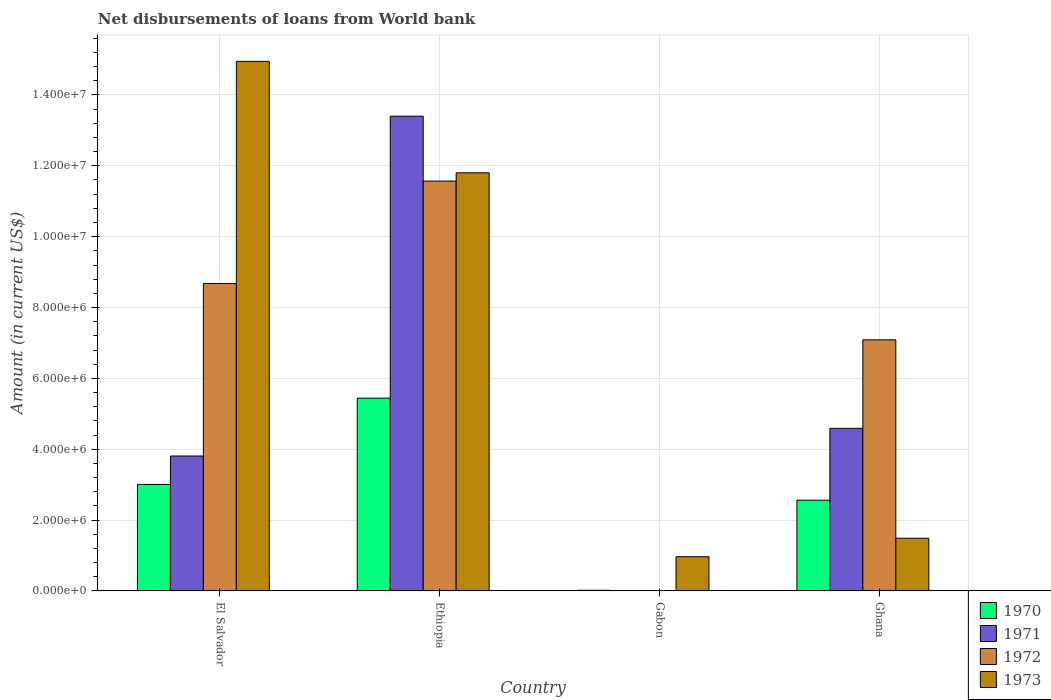How many different coloured bars are there?
Provide a succinct answer. 4. Are the number of bars per tick equal to the number of legend labels?
Your answer should be very brief. No. Are the number of bars on each tick of the X-axis equal?
Give a very brief answer. No. How many bars are there on the 1st tick from the left?
Your response must be concise. 4. What is the label of the 2nd group of bars from the left?
Keep it short and to the point. Ethiopia. In how many cases, is the number of bars for a given country not equal to the number of legend labels?
Offer a very short reply. 1. What is the amount of loan disbursed from World Bank in 1973 in Gabon?
Your answer should be very brief. 9.67e+05. Across all countries, what is the maximum amount of loan disbursed from World Bank in 1972?
Make the answer very short. 1.16e+07. In which country was the amount of loan disbursed from World Bank in 1971 maximum?
Your answer should be very brief. Ethiopia. What is the total amount of loan disbursed from World Bank in 1973 in the graph?
Provide a succinct answer. 2.92e+07. What is the difference between the amount of loan disbursed from World Bank in 1970 in Ethiopia and that in Ghana?
Offer a very short reply. 2.88e+06. What is the difference between the amount of loan disbursed from World Bank in 1972 in Ghana and the amount of loan disbursed from World Bank in 1971 in Ethiopia?
Your answer should be compact. -6.31e+06. What is the average amount of loan disbursed from World Bank in 1970 per country?
Offer a terse response. 2.76e+06. What is the difference between the amount of loan disbursed from World Bank of/in 1972 and amount of loan disbursed from World Bank of/in 1971 in Ethiopia?
Give a very brief answer. -1.83e+06. In how many countries, is the amount of loan disbursed from World Bank in 1973 greater than 800000 US$?
Your answer should be compact. 4. What is the ratio of the amount of loan disbursed from World Bank in 1971 in El Salvador to that in Ghana?
Your answer should be compact. 0.83. What is the difference between the highest and the second highest amount of loan disbursed from World Bank in 1970?
Ensure brevity in your answer.  2.44e+06. What is the difference between the highest and the lowest amount of loan disbursed from World Bank in 1970?
Ensure brevity in your answer.  5.42e+06. Is it the case that in every country, the sum of the amount of loan disbursed from World Bank in 1973 and amount of loan disbursed from World Bank in 1971 is greater than the amount of loan disbursed from World Bank in 1970?
Offer a very short reply. Yes. How many bars are there?
Your answer should be very brief. 14. How many countries are there in the graph?
Offer a terse response. 4. Are the values on the major ticks of Y-axis written in scientific E-notation?
Your answer should be compact. Yes. Does the graph contain any zero values?
Your answer should be compact. Yes. How many legend labels are there?
Make the answer very short. 4. How are the legend labels stacked?
Your answer should be very brief. Vertical. What is the title of the graph?
Give a very brief answer. Net disbursements of loans from World bank. What is the Amount (in current US$) of 1970 in El Salvador?
Your answer should be very brief. 3.01e+06. What is the Amount (in current US$) of 1971 in El Salvador?
Give a very brief answer. 3.81e+06. What is the Amount (in current US$) in 1972 in El Salvador?
Offer a very short reply. 8.68e+06. What is the Amount (in current US$) in 1973 in El Salvador?
Your answer should be compact. 1.49e+07. What is the Amount (in current US$) in 1970 in Ethiopia?
Ensure brevity in your answer.  5.44e+06. What is the Amount (in current US$) of 1971 in Ethiopia?
Offer a terse response. 1.34e+07. What is the Amount (in current US$) in 1972 in Ethiopia?
Provide a short and direct response. 1.16e+07. What is the Amount (in current US$) of 1973 in Ethiopia?
Ensure brevity in your answer.  1.18e+07. What is the Amount (in current US$) of 1970 in Gabon?
Your answer should be compact. 2.00e+04. What is the Amount (in current US$) of 1971 in Gabon?
Offer a very short reply. 0. What is the Amount (in current US$) of 1973 in Gabon?
Ensure brevity in your answer.  9.67e+05. What is the Amount (in current US$) of 1970 in Ghana?
Provide a short and direct response. 2.56e+06. What is the Amount (in current US$) of 1971 in Ghana?
Keep it short and to the point. 4.59e+06. What is the Amount (in current US$) in 1972 in Ghana?
Offer a very short reply. 7.09e+06. What is the Amount (in current US$) of 1973 in Ghana?
Provide a succinct answer. 1.49e+06. Across all countries, what is the maximum Amount (in current US$) in 1970?
Your answer should be compact. 5.44e+06. Across all countries, what is the maximum Amount (in current US$) in 1971?
Give a very brief answer. 1.34e+07. Across all countries, what is the maximum Amount (in current US$) of 1972?
Your answer should be compact. 1.16e+07. Across all countries, what is the maximum Amount (in current US$) in 1973?
Offer a very short reply. 1.49e+07. Across all countries, what is the minimum Amount (in current US$) of 1970?
Ensure brevity in your answer.  2.00e+04. Across all countries, what is the minimum Amount (in current US$) of 1971?
Your answer should be very brief. 0. Across all countries, what is the minimum Amount (in current US$) in 1972?
Your answer should be compact. 0. Across all countries, what is the minimum Amount (in current US$) of 1973?
Offer a very short reply. 9.67e+05. What is the total Amount (in current US$) of 1970 in the graph?
Ensure brevity in your answer.  1.10e+07. What is the total Amount (in current US$) of 1971 in the graph?
Keep it short and to the point. 2.18e+07. What is the total Amount (in current US$) in 1972 in the graph?
Provide a succinct answer. 2.73e+07. What is the total Amount (in current US$) of 1973 in the graph?
Keep it short and to the point. 2.92e+07. What is the difference between the Amount (in current US$) of 1970 in El Salvador and that in Ethiopia?
Your answer should be compact. -2.44e+06. What is the difference between the Amount (in current US$) in 1971 in El Salvador and that in Ethiopia?
Provide a short and direct response. -9.59e+06. What is the difference between the Amount (in current US$) of 1972 in El Salvador and that in Ethiopia?
Your answer should be very brief. -2.89e+06. What is the difference between the Amount (in current US$) of 1973 in El Salvador and that in Ethiopia?
Provide a short and direct response. 3.15e+06. What is the difference between the Amount (in current US$) in 1970 in El Salvador and that in Gabon?
Your answer should be very brief. 2.99e+06. What is the difference between the Amount (in current US$) of 1973 in El Salvador and that in Gabon?
Make the answer very short. 1.40e+07. What is the difference between the Amount (in current US$) in 1970 in El Salvador and that in Ghana?
Keep it short and to the point. 4.45e+05. What is the difference between the Amount (in current US$) in 1971 in El Salvador and that in Ghana?
Keep it short and to the point. -7.81e+05. What is the difference between the Amount (in current US$) in 1972 in El Salvador and that in Ghana?
Give a very brief answer. 1.59e+06. What is the difference between the Amount (in current US$) in 1973 in El Salvador and that in Ghana?
Keep it short and to the point. 1.35e+07. What is the difference between the Amount (in current US$) in 1970 in Ethiopia and that in Gabon?
Your response must be concise. 5.42e+06. What is the difference between the Amount (in current US$) in 1973 in Ethiopia and that in Gabon?
Keep it short and to the point. 1.08e+07. What is the difference between the Amount (in current US$) of 1970 in Ethiopia and that in Ghana?
Keep it short and to the point. 2.88e+06. What is the difference between the Amount (in current US$) of 1971 in Ethiopia and that in Ghana?
Your answer should be very brief. 8.81e+06. What is the difference between the Amount (in current US$) of 1972 in Ethiopia and that in Ghana?
Your answer should be very brief. 4.48e+06. What is the difference between the Amount (in current US$) of 1973 in Ethiopia and that in Ghana?
Your answer should be compact. 1.03e+07. What is the difference between the Amount (in current US$) in 1970 in Gabon and that in Ghana?
Provide a succinct answer. -2.54e+06. What is the difference between the Amount (in current US$) in 1973 in Gabon and that in Ghana?
Provide a succinct answer. -5.21e+05. What is the difference between the Amount (in current US$) of 1970 in El Salvador and the Amount (in current US$) of 1971 in Ethiopia?
Offer a very short reply. -1.04e+07. What is the difference between the Amount (in current US$) in 1970 in El Salvador and the Amount (in current US$) in 1972 in Ethiopia?
Your answer should be very brief. -8.56e+06. What is the difference between the Amount (in current US$) in 1970 in El Salvador and the Amount (in current US$) in 1973 in Ethiopia?
Ensure brevity in your answer.  -8.80e+06. What is the difference between the Amount (in current US$) of 1971 in El Salvador and the Amount (in current US$) of 1972 in Ethiopia?
Give a very brief answer. -7.76e+06. What is the difference between the Amount (in current US$) of 1971 in El Salvador and the Amount (in current US$) of 1973 in Ethiopia?
Your response must be concise. -7.99e+06. What is the difference between the Amount (in current US$) in 1972 in El Salvador and the Amount (in current US$) in 1973 in Ethiopia?
Your answer should be very brief. -3.12e+06. What is the difference between the Amount (in current US$) in 1970 in El Salvador and the Amount (in current US$) in 1973 in Gabon?
Provide a succinct answer. 2.04e+06. What is the difference between the Amount (in current US$) in 1971 in El Salvador and the Amount (in current US$) in 1973 in Gabon?
Keep it short and to the point. 2.84e+06. What is the difference between the Amount (in current US$) of 1972 in El Salvador and the Amount (in current US$) of 1973 in Gabon?
Your answer should be very brief. 7.71e+06. What is the difference between the Amount (in current US$) of 1970 in El Salvador and the Amount (in current US$) of 1971 in Ghana?
Ensure brevity in your answer.  -1.58e+06. What is the difference between the Amount (in current US$) in 1970 in El Salvador and the Amount (in current US$) in 1972 in Ghana?
Make the answer very short. -4.08e+06. What is the difference between the Amount (in current US$) of 1970 in El Salvador and the Amount (in current US$) of 1973 in Ghana?
Ensure brevity in your answer.  1.52e+06. What is the difference between the Amount (in current US$) in 1971 in El Salvador and the Amount (in current US$) in 1972 in Ghana?
Your response must be concise. -3.28e+06. What is the difference between the Amount (in current US$) of 1971 in El Salvador and the Amount (in current US$) of 1973 in Ghana?
Offer a terse response. 2.32e+06. What is the difference between the Amount (in current US$) of 1972 in El Salvador and the Amount (in current US$) of 1973 in Ghana?
Ensure brevity in your answer.  7.19e+06. What is the difference between the Amount (in current US$) in 1970 in Ethiopia and the Amount (in current US$) in 1973 in Gabon?
Provide a succinct answer. 4.48e+06. What is the difference between the Amount (in current US$) in 1971 in Ethiopia and the Amount (in current US$) in 1973 in Gabon?
Your answer should be compact. 1.24e+07. What is the difference between the Amount (in current US$) of 1972 in Ethiopia and the Amount (in current US$) of 1973 in Gabon?
Offer a very short reply. 1.06e+07. What is the difference between the Amount (in current US$) of 1970 in Ethiopia and the Amount (in current US$) of 1971 in Ghana?
Keep it short and to the point. 8.51e+05. What is the difference between the Amount (in current US$) of 1970 in Ethiopia and the Amount (in current US$) of 1972 in Ghana?
Keep it short and to the point. -1.65e+06. What is the difference between the Amount (in current US$) in 1970 in Ethiopia and the Amount (in current US$) in 1973 in Ghana?
Provide a short and direct response. 3.95e+06. What is the difference between the Amount (in current US$) of 1971 in Ethiopia and the Amount (in current US$) of 1972 in Ghana?
Your response must be concise. 6.31e+06. What is the difference between the Amount (in current US$) in 1971 in Ethiopia and the Amount (in current US$) in 1973 in Ghana?
Provide a succinct answer. 1.19e+07. What is the difference between the Amount (in current US$) of 1972 in Ethiopia and the Amount (in current US$) of 1973 in Ghana?
Keep it short and to the point. 1.01e+07. What is the difference between the Amount (in current US$) in 1970 in Gabon and the Amount (in current US$) in 1971 in Ghana?
Give a very brief answer. -4.57e+06. What is the difference between the Amount (in current US$) in 1970 in Gabon and the Amount (in current US$) in 1972 in Ghana?
Offer a terse response. -7.07e+06. What is the difference between the Amount (in current US$) of 1970 in Gabon and the Amount (in current US$) of 1973 in Ghana?
Keep it short and to the point. -1.47e+06. What is the average Amount (in current US$) in 1970 per country?
Make the answer very short. 2.76e+06. What is the average Amount (in current US$) in 1971 per country?
Make the answer very short. 5.45e+06. What is the average Amount (in current US$) in 1972 per country?
Ensure brevity in your answer.  6.83e+06. What is the average Amount (in current US$) of 1973 per country?
Offer a very short reply. 7.30e+06. What is the difference between the Amount (in current US$) of 1970 and Amount (in current US$) of 1971 in El Salvador?
Your answer should be very brief. -8.03e+05. What is the difference between the Amount (in current US$) in 1970 and Amount (in current US$) in 1972 in El Salvador?
Your answer should be very brief. -5.67e+06. What is the difference between the Amount (in current US$) of 1970 and Amount (in current US$) of 1973 in El Salvador?
Your answer should be very brief. -1.19e+07. What is the difference between the Amount (in current US$) in 1971 and Amount (in current US$) in 1972 in El Salvador?
Offer a terse response. -4.87e+06. What is the difference between the Amount (in current US$) of 1971 and Amount (in current US$) of 1973 in El Salvador?
Offer a very short reply. -1.11e+07. What is the difference between the Amount (in current US$) in 1972 and Amount (in current US$) in 1973 in El Salvador?
Provide a short and direct response. -6.27e+06. What is the difference between the Amount (in current US$) in 1970 and Amount (in current US$) in 1971 in Ethiopia?
Offer a very short reply. -7.96e+06. What is the difference between the Amount (in current US$) in 1970 and Amount (in current US$) in 1972 in Ethiopia?
Offer a terse response. -6.13e+06. What is the difference between the Amount (in current US$) in 1970 and Amount (in current US$) in 1973 in Ethiopia?
Your answer should be compact. -6.36e+06. What is the difference between the Amount (in current US$) in 1971 and Amount (in current US$) in 1972 in Ethiopia?
Your answer should be very brief. 1.83e+06. What is the difference between the Amount (in current US$) of 1971 and Amount (in current US$) of 1973 in Ethiopia?
Your response must be concise. 1.60e+06. What is the difference between the Amount (in current US$) in 1972 and Amount (in current US$) in 1973 in Ethiopia?
Your answer should be compact. -2.33e+05. What is the difference between the Amount (in current US$) in 1970 and Amount (in current US$) in 1973 in Gabon?
Your answer should be very brief. -9.47e+05. What is the difference between the Amount (in current US$) in 1970 and Amount (in current US$) in 1971 in Ghana?
Give a very brief answer. -2.03e+06. What is the difference between the Amount (in current US$) in 1970 and Amount (in current US$) in 1972 in Ghana?
Make the answer very short. -4.53e+06. What is the difference between the Amount (in current US$) of 1970 and Amount (in current US$) of 1973 in Ghana?
Keep it short and to the point. 1.07e+06. What is the difference between the Amount (in current US$) in 1971 and Amount (in current US$) in 1972 in Ghana?
Keep it short and to the point. -2.50e+06. What is the difference between the Amount (in current US$) in 1971 and Amount (in current US$) in 1973 in Ghana?
Your answer should be compact. 3.10e+06. What is the difference between the Amount (in current US$) in 1972 and Amount (in current US$) in 1973 in Ghana?
Your response must be concise. 5.60e+06. What is the ratio of the Amount (in current US$) of 1970 in El Salvador to that in Ethiopia?
Ensure brevity in your answer.  0.55. What is the ratio of the Amount (in current US$) of 1971 in El Salvador to that in Ethiopia?
Provide a short and direct response. 0.28. What is the ratio of the Amount (in current US$) of 1972 in El Salvador to that in Ethiopia?
Your response must be concise. 0.75. What is the ratio of the Amount (in current US$) of 1973 in El Salvador to that in Ethiopia?
Your answer should be compact. 1.27. What is the ratio of the Amount (in current US$) of 1970 in El Salvador to that in Gabon?
Make the answer very short. 150.35. What is the ratio of the Amount (in current US$) in 1973 in El Salvador to that in Gabon?
Offer a very short reply. 15.46. What is the ratio of the Amount (in current US$) in 1970 in El Salvador to that in Ghana?
Provide a succinct answer. 1.17. What is the ratio of the Amount (in current US$) in 1971 in El Salvador to that in Ghana?
Offer a very short reply. 0.83. What is the ratio of the Amount (in current US$) in 1972 in El Salvador to that in Ghana?
Provide a succinct answer. 1.22. What is the ratio of the Amount (in current US$) in 1973 in El Salvador to that in Ghana?
Your response must be concise. 10.05. What is the ratio of the Amount (in current US$) of 1970 in Ethiopia to that in Gabon?
Offer a terse response. 272.1. What is the ratio of the Amount (in current US$) in 1973 in Ethiopia to that in Gabon?
Offer a very short reply. 12.2. What is the ratio of the Amount (in current US$) of 1970 in Ethiopia to that in Ghana?
Provide a succinct answer. 2.12. What is the ratio of the Amount (in current US$) of 1971 in Ethiopia to that in Ghana?
Offer a terse response. 2.92. What is the ratio of the Amount (in current US$) in 1972 in Ethiopia to that in Ghana?
Your answer should be very brief. 1.63. What is the ratio of the Amount (in current US$) in 1973 in Ethiopia to that in Ghana?
Make the answer very short. 7.93. What is the ratio of the Amount (in current US$) in 1970 in Gabon to that in Ghana?
Offer a terse response. 0.01. What is the ratio of the Amount (in current US$) of 1973 in Gabon to that in Ghana?
Make the answer very short. 0.65. What is the difference between the highest and the second highest Amount (in current US$) in 1970?
Make the answer very short. 2.44e+06. What is the difference between the highest and the second highest Amount (in current US$) in 1971?
Your response must be concise. 8.81e+06. What is the difference between the highest and the second highest Amount (in current US$) of 1972?
Offer a very short reply. 2.89e+06. What is the difference between the highest and the second highest Amount (in current US$) in 1973?
Ensure brevity in your answer.  3.15e+06. What is the difference between the highest and the lowest Amount (in current US$) in 1970?
Offer a terse response. 5.42e+06. What is the difference between the highest and the lowest Amount (in current US$) of 1971?
Give a very brief answer. 1.34e+07. What is the difference between the highest and the lowest Amount (in current US$) in 1972?
Make the answer very short. 1.16e+07. What is the difference between the highest and the lowest Amount (in current US$) in 1973?
Provide a succinct answer. 1.40e+07. 